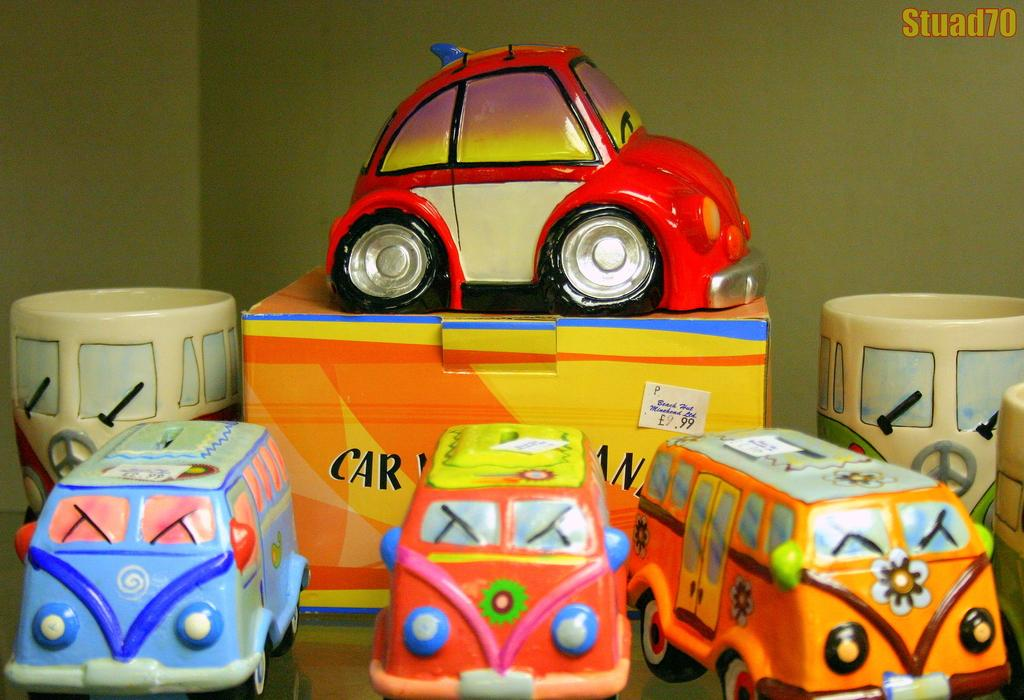What type of objects can be seen in the image? There are toys in the image. Can you describe the toys on the table? There are cars on the table in the image. What color is the wall visible in the background of the image? The wall visible in the background of the image is green. What type of caption is written on the toys in the image? There is no caption written on the toys in the image. 